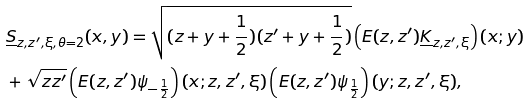Convert formula to latex. <formula><loc_0><loc_0><loc_500><loc_500>& \underline { S } _ { z , z ^ { \prime } , \xi , \theta = 2 } ( x , y ) = \sqrt { ( z + y + \frac { 1 } { 2 } ) ( z ^ { \prime } + y + \frac { 1 } { 2 } ) } \left ( E ( z , z ^ { \prime } ) \underline { K } _ { z , z ^ { \prime } , \xi } \right ) ( x ; y ) \\ & + \sqrt { z z ^ { \prime } } \left ( E ( z , z ^ { \prime } ) \psi _ { - \frac { 1 } { 2 } } \right ) ( x ; z , z ^ { \prime } , \xi ) \left ( E ( z , z ^ { \prime } ) \psi _ { \frac { 1 } { 2 } } \right ) ( y ; z , z ^ { \prime } , \xi ) ,</formula> 